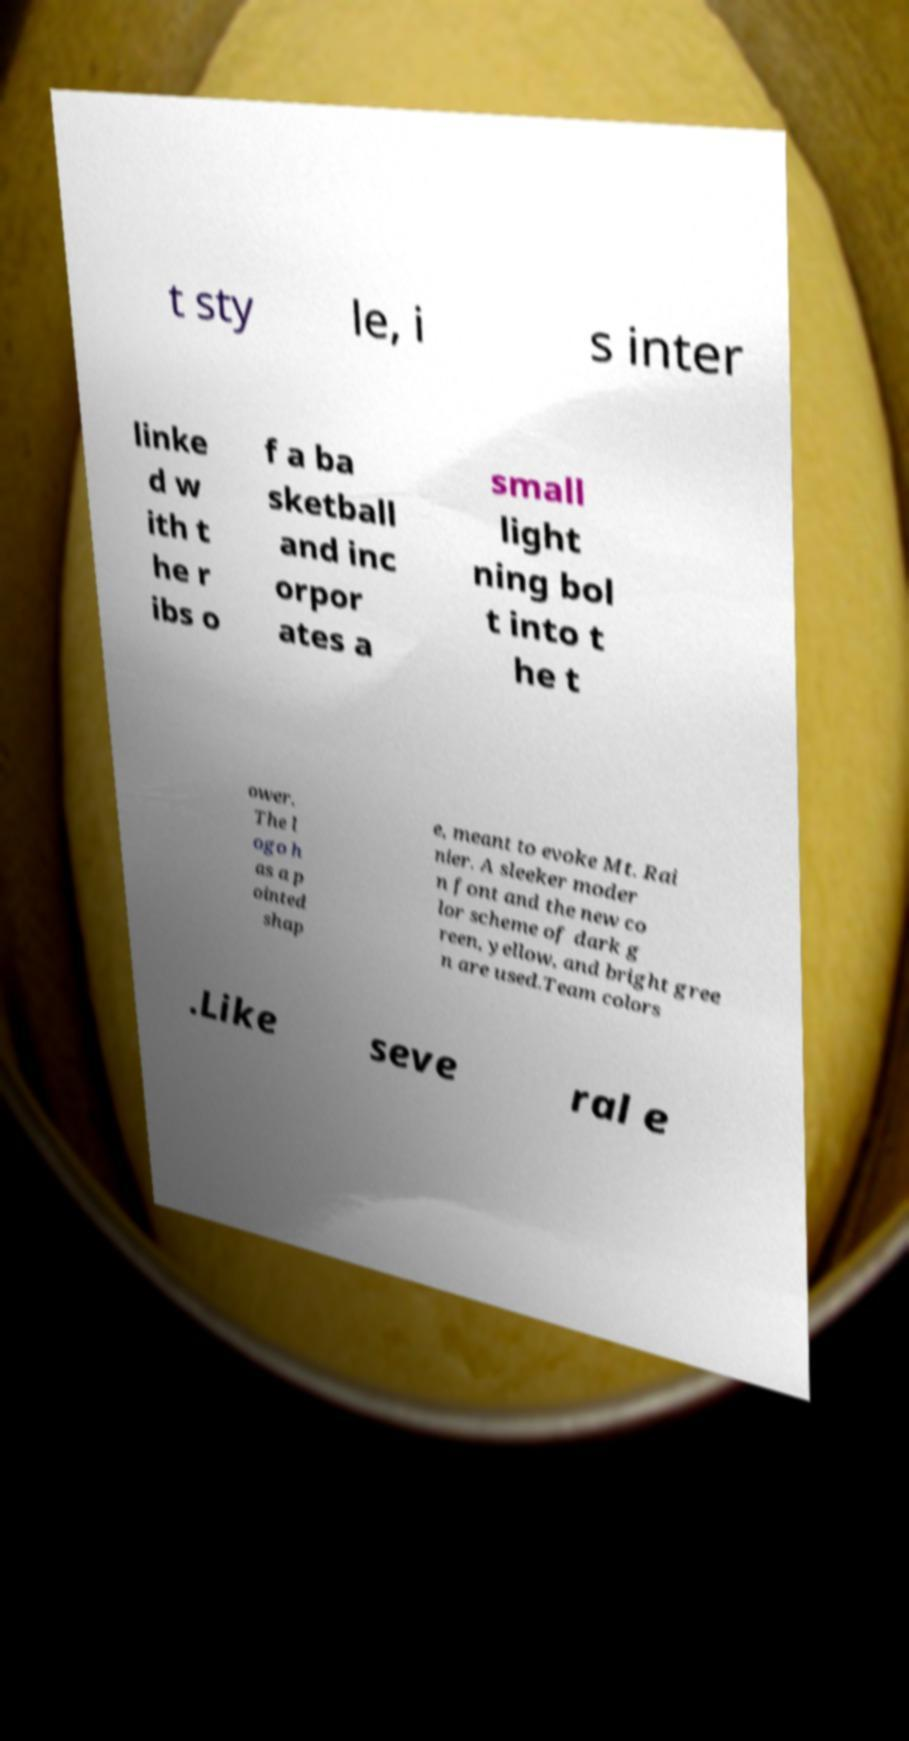What messages or text are displayed in this image? I need them in a readable, typed format. t sty le, i s inter linke d w ith t he r ibs o f a ba sketball and inc orpor ates a small light ning bol t into t he t ower. The l ogo h as a p ointed shap e, meant to evoke Mt. Rai nier. A sleeker moder n font and the new co lor scheme of dark g reen, yellow, and bright gree n are used.Team colors .Like seve ral e 